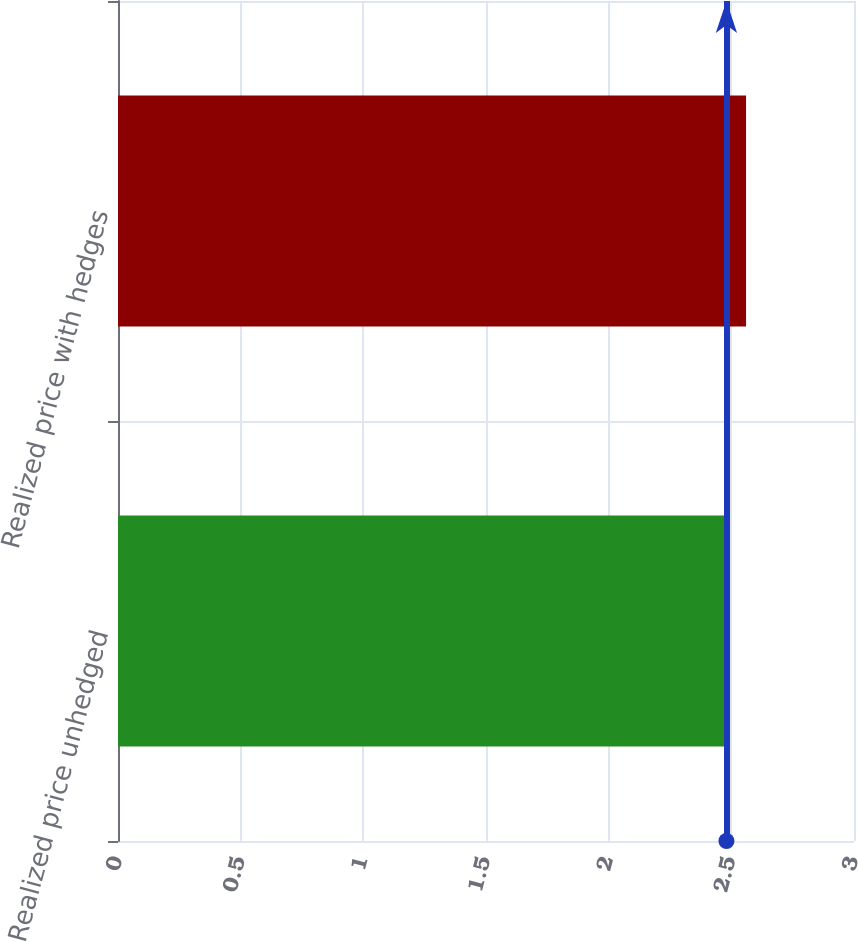<chart> <loc_0><loc_0><loc_500><loc_500><bar_chart><fcel>Realized price unhedged<fcel>Realized price with hedges<nl><fcel>2.48<fcel>2.56<nl></chart> 